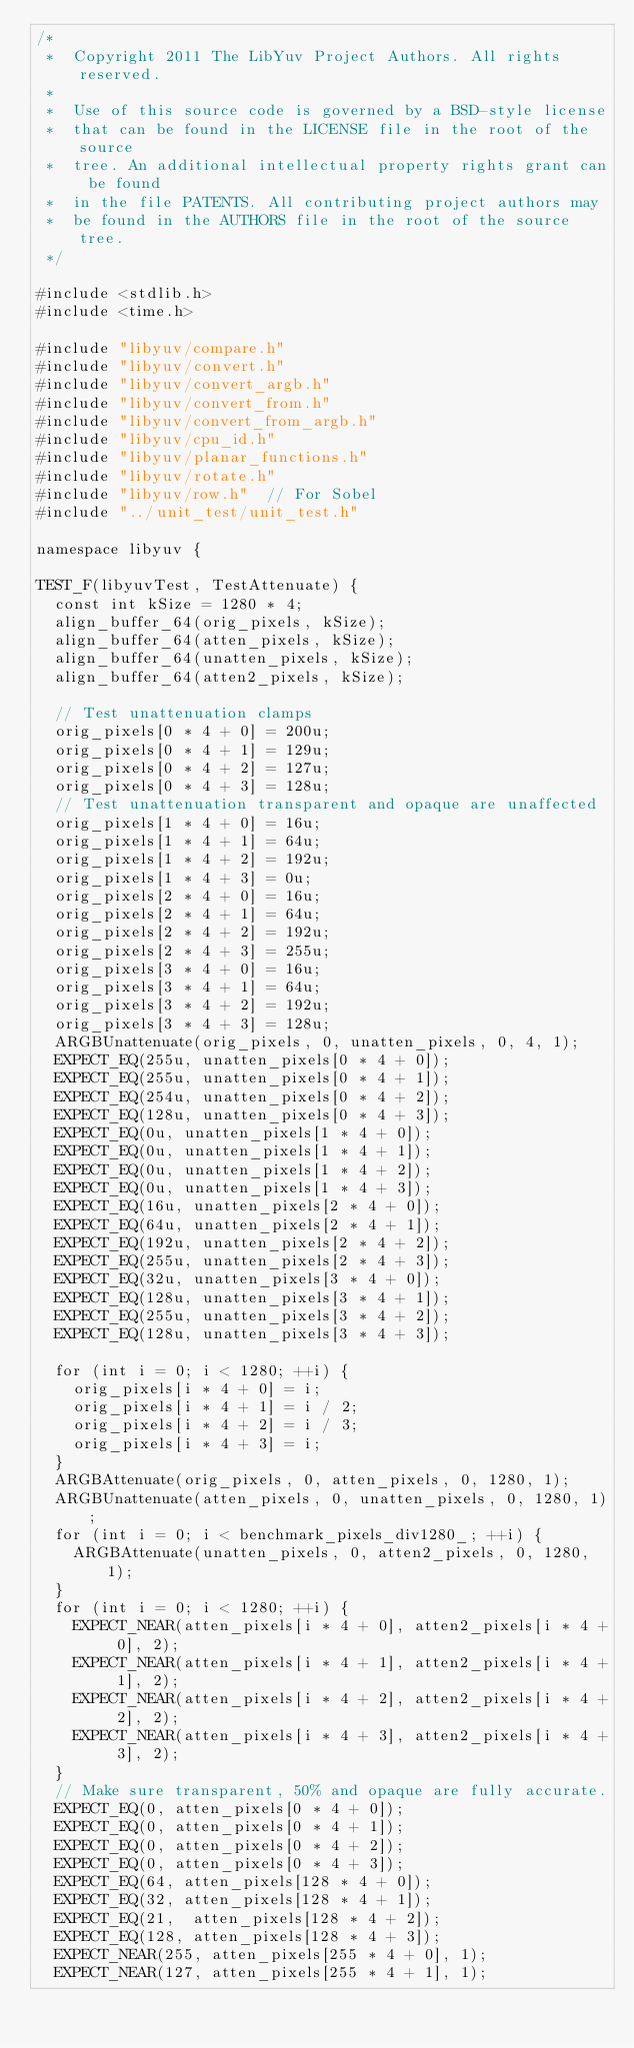<code> <loc_0><loc_0><loc_500><loc_500><_C++_>/*
 *  Copyright 2011 The LibYuv Project Authors. All rights reserved.
 *
 *  Use of this source code is governed by a BSD-style license
 *  that can be found in the LICENSE file in the root of the source
 *  tree. An additional intellectual property rights grant can be found
 *  in the file PATENTS. All contributing project authors may
 *  be found in the AUTHORS file in the root of the source tree.
 */

#include <stdlib.h>
#include <time.h>

#include "libyuv/compare.h"
#include "libyuv/convert.h"
#include "libyuv/convert_argb.h"
#include "libyuv/convert_from.h"
#include "libyuv/convert_from_argb.h"
#include "libyuv/cpu_id.h"
#include "libyuv/planar_functions.h"
#include "libyuv/rotate.h"
#include "libyuv/row.h"  // For Sobel
#include "../unit_test/unit_test.h"

namespace libyuv {

TEST_F(libyuvTest, TestAttenuate) {
  const int kSize = 1280 * 4;
  align_buffer_64(orig_pixels, kSize);
  align_buffer_64(atten_pixels, kSize);
  align_buffer_64(unatten_pixels, kSize);
  align_buffer_64(atten2_pixels, kSize);

  // Test unattenuation clamps
  orig_pixels[0 * 4 + 0] = 200u;
  orig_pixels[0 * 4 + 1] = 129u;
  orig_pixels[0 * 4 + 2] = 127u;
  orig_pixels[0 * 4 + 3] = 128u;
  // Test unattenuation transparent and opaque are unaffected
  orig_pixels[1 * 4 + 0] = 16u;
  orig_pixels[1 * 4 + 1] = 64u;
  orig_pixels[1 * 4 + 2] = 192u;
  orig_pixels[1 * 4 + 3] = 0u;
  orig_pixels[2 * 4 + 0] = 16u;
  orig_pixels[2 * 4 + 1] = 64u;
  orig_pixels[2 * 4 + 2] = 192u;
  orig_pixels[2 * 4 + 3] = 255u;
  orig_pixels[3 * 4 + 0] = 16u;
  orig_pixels[3 * 4 + 1] = 64u;
  orig_pixels[3 * 4 + 2] = 192u;
  orig_pixels[3 * 4 + 3] = 128u;
  ARGBUnattenuate(orig_pixels, 0, unatten_pixels, 0, 4, 1);
  EXPECT_EQ(255u, unatten_pixels[0 * 4 + 0]);
  EXPECT_EQ(255u, unatten_pixels[0 * 4 + 1]);
  EXPECT_EQ(254u, unatten_pixels[0 * 4 + 2]);
  EXPECT_EQ(128u, unatten_pixels[0 * 4 + 3]);
  EXPECT_EQ(0u, unatten_pixels[1 * 4 + 0]);
  EXPECT_EQ(0u, unatten_pixels[1 * 4 + 1]);
  EXPECT_EQ(0u, unatten_pixels[1 * 4 + 2]);
  EXPECT_EQ(0u, unatten_pixels[1 * 4 + 3]);
  EXPECT_EQ(16u, unatten_pixels[2 * 4 + 0]);
  EXPECT_EQ(64u, unatten_pixels[2 * 4 + 1]);
  EXPECT_EQ(192u, unatten_pixels[2 * 4 + 2]);
  EXPECT_EQ(255u, unatten_pixels[2 * 4 + 3]);
  EXPECT_EQ(32u, unatten_pixels[3 * 4 + 0]);
  EXPECT_EQ(128u, unatten_pixels[3 * 4 + 1]);
  EXPECT_EQ(255u, unatten_pixels[3 * 4 + 2]);
  EXPECT_EQ(128u, unatten_pixels[3 * 4 + 3]);

  for (int i = 0; i < 1280; ++i) {
    orig_pixels[i * 4 + 0] = i;
    orig_pixels[i * 4 + 1] = i / 2;
    orig_pixels[i * 4 + 2] = i / 3;
    orig_pixels[i * 4 + 3] = i;
  }
  ARGBAttenuate(orig_pixels, 0, atten_pixels, 0, 1280, 1);
  ARGBUnattenuate(atten_pixels, 0, unatten_pixels, 0, 1280, 1);
  for (int i = 0; i < benchmark_pixels_div1280_; ++i) {
    ARGBAttenuate(unatten_pixels, 0, atten2_pixels, 0, 1280, 1);
  }
  for (int i = 0; i < 1280; ++i) {
    EXPECT_NEAR(atten_pixels[i * 4 + 0], atten2_pixels[i * 4 + 0], 2);
    EXPECT_NEAR(atten_pixels[i * 4 + 1], atten2_pixels[i * 4 + 1], 2);
    EXPECT_NEAR(atten_pixels[i * 4 + 2], atten2_pixels[i * 4 + 2], 2);
    EXPECT_NEAR(atten_pixels[i * 4 + 3], atten2_pixels[i * 4 + 3], 2);
  }
  // Make sure transparent, 50% and opaque are fully accurate.
  EXPECT_EQ(0, atten_pixels[0 * 4 + 0]);
  EXPECT_EQ(0, atten_pixels[0 * 4 + 1]);
  EXPECT_EQ(0, atten_pixels[0 * 4 + 2]);
  EXPECT_EQ(0, atten_pixels[0 * 4 + 3]);
  EXPECT_EQ(64, atten_pixels[128 * 4 + 0]);
  EXPECT_EQ(32, atten_pixels[128 * 4 + 1]);
  EXPECT_EQ(21,  atten_pixels[128 * 4 + 2]);
  EXPECT_EQ(128, atten_pixels[128 * 4 + 3]);
  EXPECT_NEAR(255, atten_pixels[255 * 4 + 0], 1);
  EXPECT_NEAR(127, atten_pixels[255 * 4 + 1], 1);</code> 